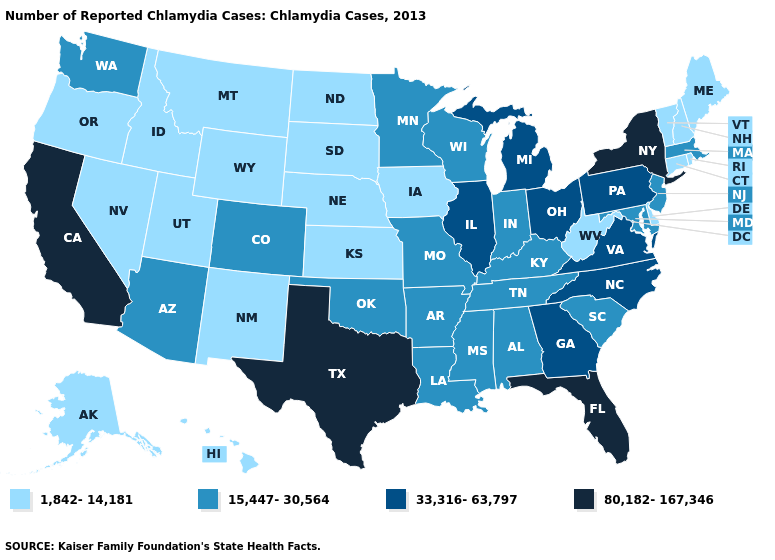What is the highest value in the South ?
Short answer required. 80,182-167,346. What is the highest value in the West ?
Give a very brief answer. 80,182-167,346. Among the states that border Nebraska , which have the highest value?
Quick response, please. Colorado, Missouri. Name the states that have a value in the range 80,182-167,346?
Keep it brief. California, Florida, New York, Texas. Does the first symbol in the legend represent the smallest category?
Concise answer only. Yes. Does the first symbol in the legend represent the smallest category?
Be succinct. Yes. Name the states that have a value in the range 15,447-30,564?
Be succinct. Alabama, Arizona, Arkansas, Colorado, Indiana, Kentucky, Louisiana, Maryland, Massachusetts, Minnesota, Mississippi, Missouri, New Jersey, Oklahoma, South Carolina, Tennessee, Washington, Wisconsin. What is the value of Oklahoma?
Write a very short answer. 15,447-30,564. Name the states that have a value in the range 33,316-63,797?
Give a very brief answer. Georgia, Illinois, Michigan, North Carolina, Ohio, Pennsylvania, Virginia. Which states hav the highest value in the Northeast?
Be succinct. New York. Does Michigan have the highest value in the MidWest?
Answer briefly. Yes. Does the map have missing data?
Quick response, please. No. Among the states that border Rhode Island , does Massachusetts have the highest value?
Write a very short answer. Yes. Name the states that have a value in the range 33,316-63,797?
Be succinct. Georgia, Illinois, Michigan, North Carolina, Ohio, Pennsylvania, Virginia. Name the states that have a value in the range 80,182-167,346?
Answer briefly. California, Florida, New York, Texas. 